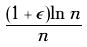<formula> <loc_0><loc_0><loc_500><loc_500>\frac { ( 1 + \epsilon ) \ln n } { n }</formula> 